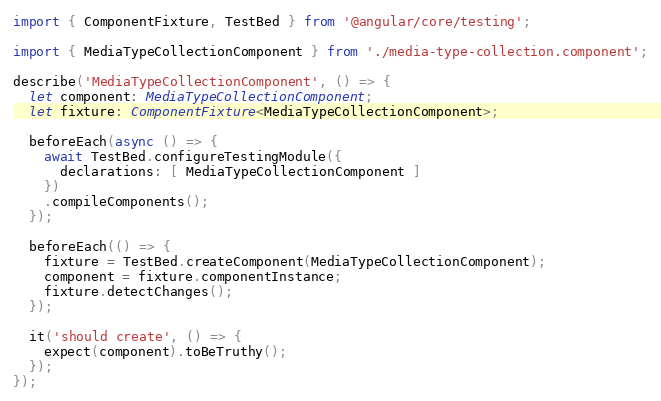<code> <loc_0><loc_0><loc_500><loc_500><_TypeScript_>import { ComponentFixture, TestBed } from '@angular/core/testing';

import { MediaTypeCollectionComponent } from './media-type-collection.component';

describe('MediaTypeCollectionComponent', () => {
  let component: MediaTypeCollectionComponent;
  let fixture: ComponentFixture<MediaTypeCollectionComponent>;

  beforeEach(async () => {
    await TestBed.configureTestingModule({
      declarations: [ MediaTypeCollectionComponent ]
    })
    .compileComponents();
  });

  beforeEach(() => {
    fixture = TestBed.createComponent(MediaTypeCollectionComponent);
    component = fixture.componentInstance;
    fixture.detectChanges();
  });

  it('should create', () => {
    expect(component).toBeTruthy();
  });
});
</code> 